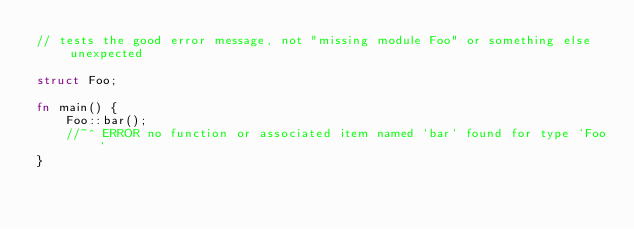Convert code to text. <code><loc_0><loc_0><loc_500><loc_500><_Rust_>// tests the good error message, not "missing module Foo" or something else unexpected

struct Foo;

fn main() {
    Foo::bar();
    //~^ ERROR no function or associated item named `bar` found for type `Foo`
}
</code> 